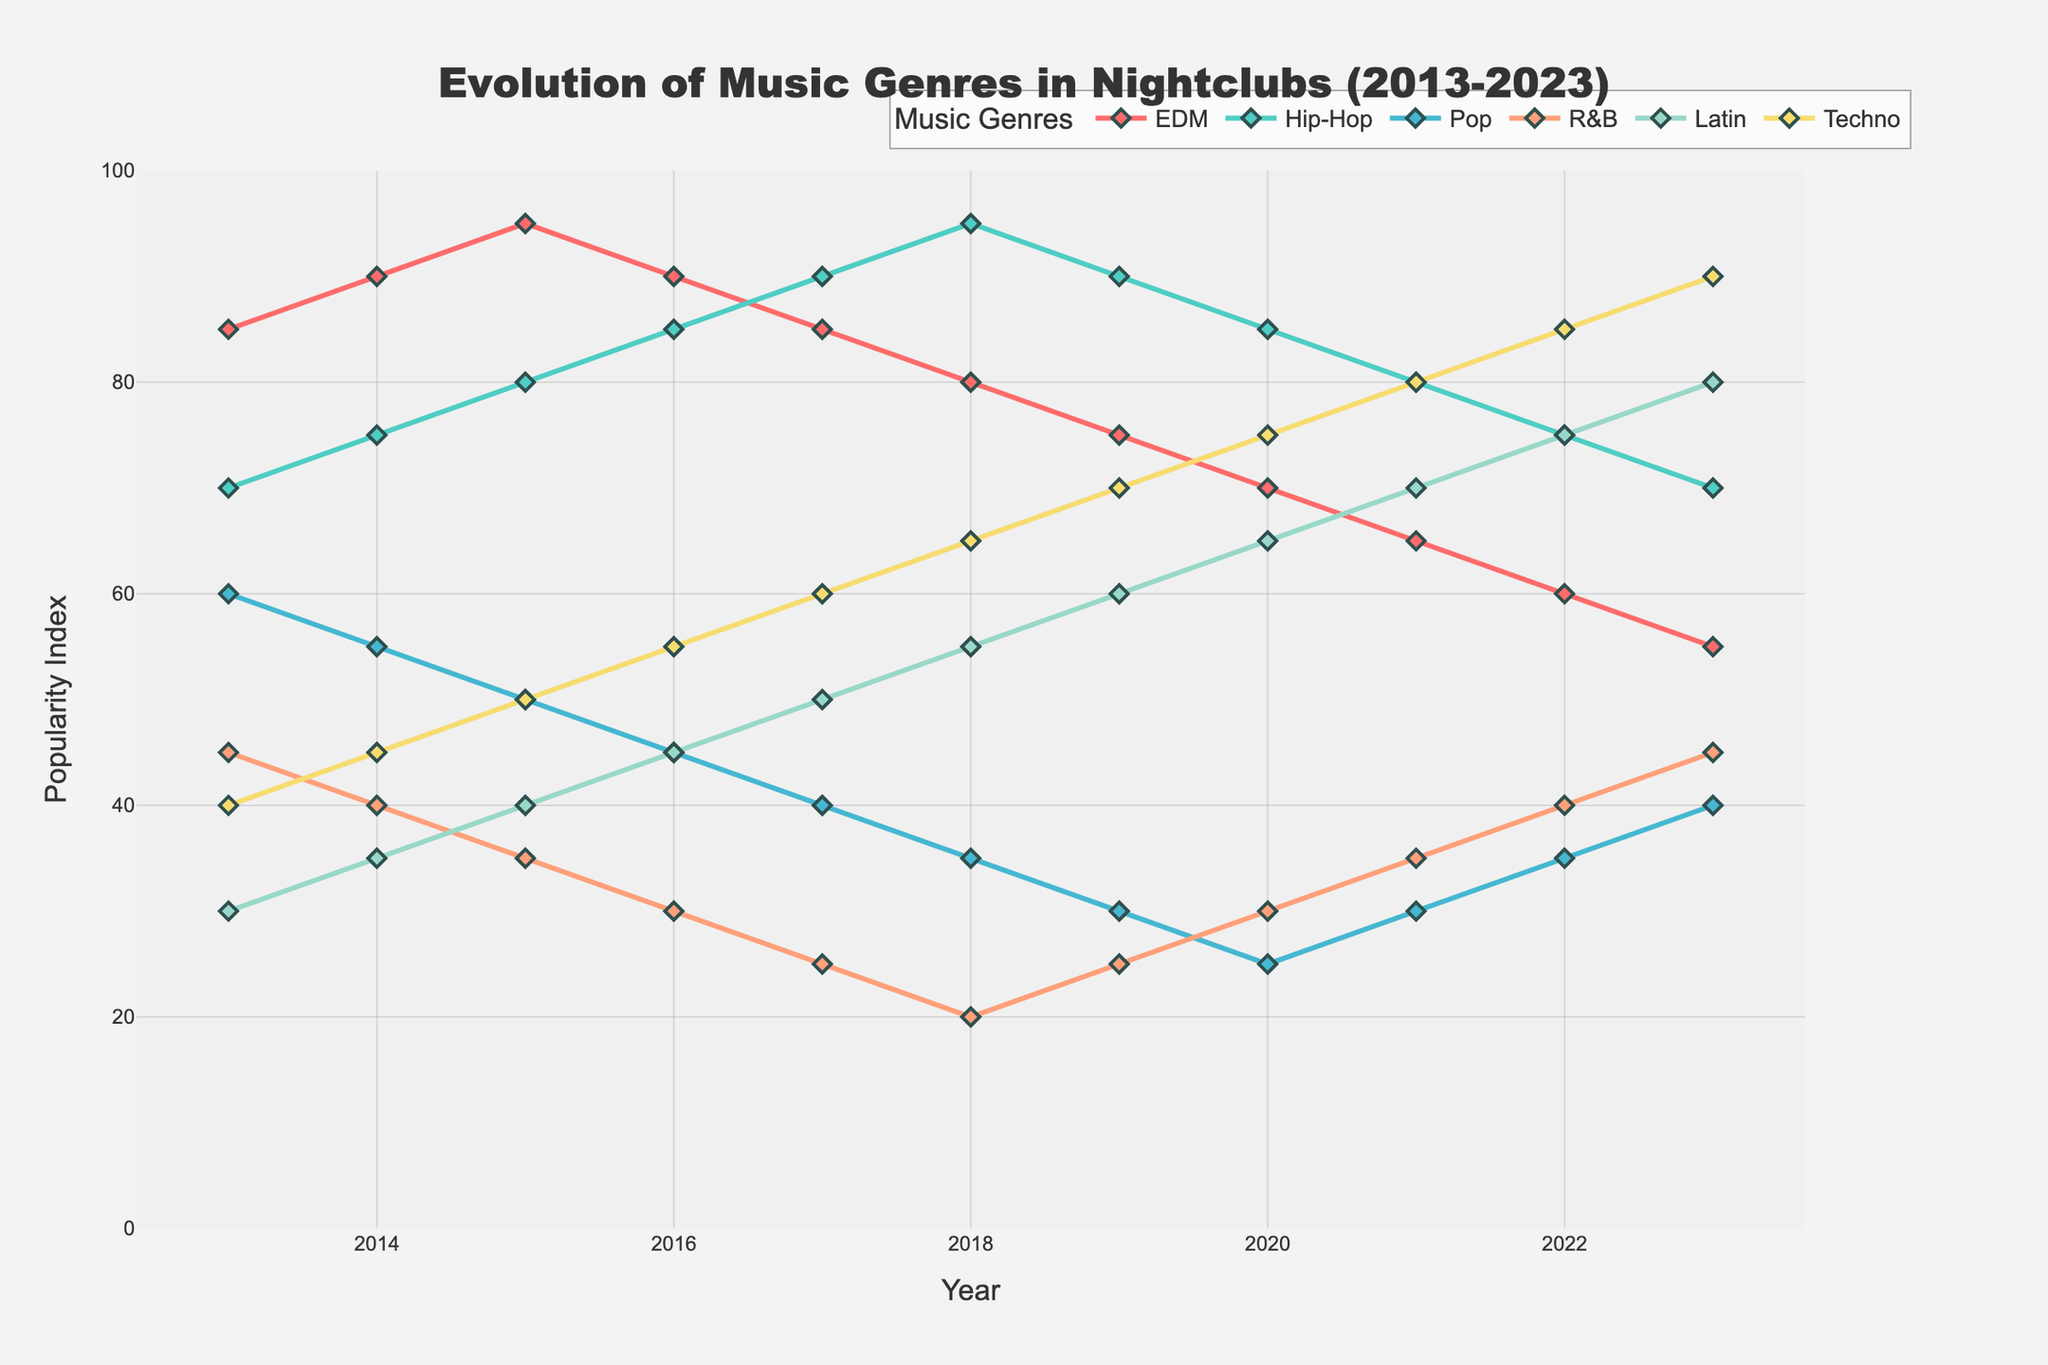What genre experienced the greatest decrease in popularity from 2016 to 2023? To find the greatest decrease, calculate the difference between the popularity index of each genre for the years 2016 and 2023. EDM decreased from 90 to 55 (35 points), Hip-Hop increased, Pop decreased from 45 to 40 (5 points), R&B increased, Latin increased, and Techno increased. EDM saw the biggest decrease.
Answer: EDM Between which two years did Latin music see the highest increase in popularity? Look at the Latin genre trend line and find the pair of consecutive years with the largest difference in value. From 2019 to 2020, Latin increased from 60 to 65, a difference of 5, which is the highest.
Answer: 2019 to 2020 Which genre surpassed EDM in popularity first and in which year? Observe the points where each genre's line crosses the EDM line. Hip-Hop surpasses EDM in 2016.
Answer: Hip-Hop, 2016 Did Techno's popularity increase every year? Check the Techno line from 2013 to 2023 and note any declines. Techno increased steadily each year without any decline.
Answer: Yes How many years did Hip-Hop remain the most popular genre? Determine the years when Hip-Hop has the highest index compared to other genres. Hip-Hop is the most popular from 2016 to 2023, which totals 8 years.
Answer: 8 years Which two genres showed a trend of decreasing popularity while others were increasing from 2013 to 2023? Identify which lines are generally descending while the rest are rising. EDM and Pop show a decreasing trend over the decade.
Answer: EDM and Pop What's the average popularity index of R&B over the decade? Sum up the R&B values from 2013 to 2023 and divide by the number of years (11). (45+40+35+30+25+20+25+30+35+40+45)/11 = 32.27.
Answer: 32.27 In which year did Latin music equal or surpass more than one genre? Look for the year where Latin crosses the lines of other genres. In 2022, Latin surpasses both R&B and Pop.
Answer: 2022 